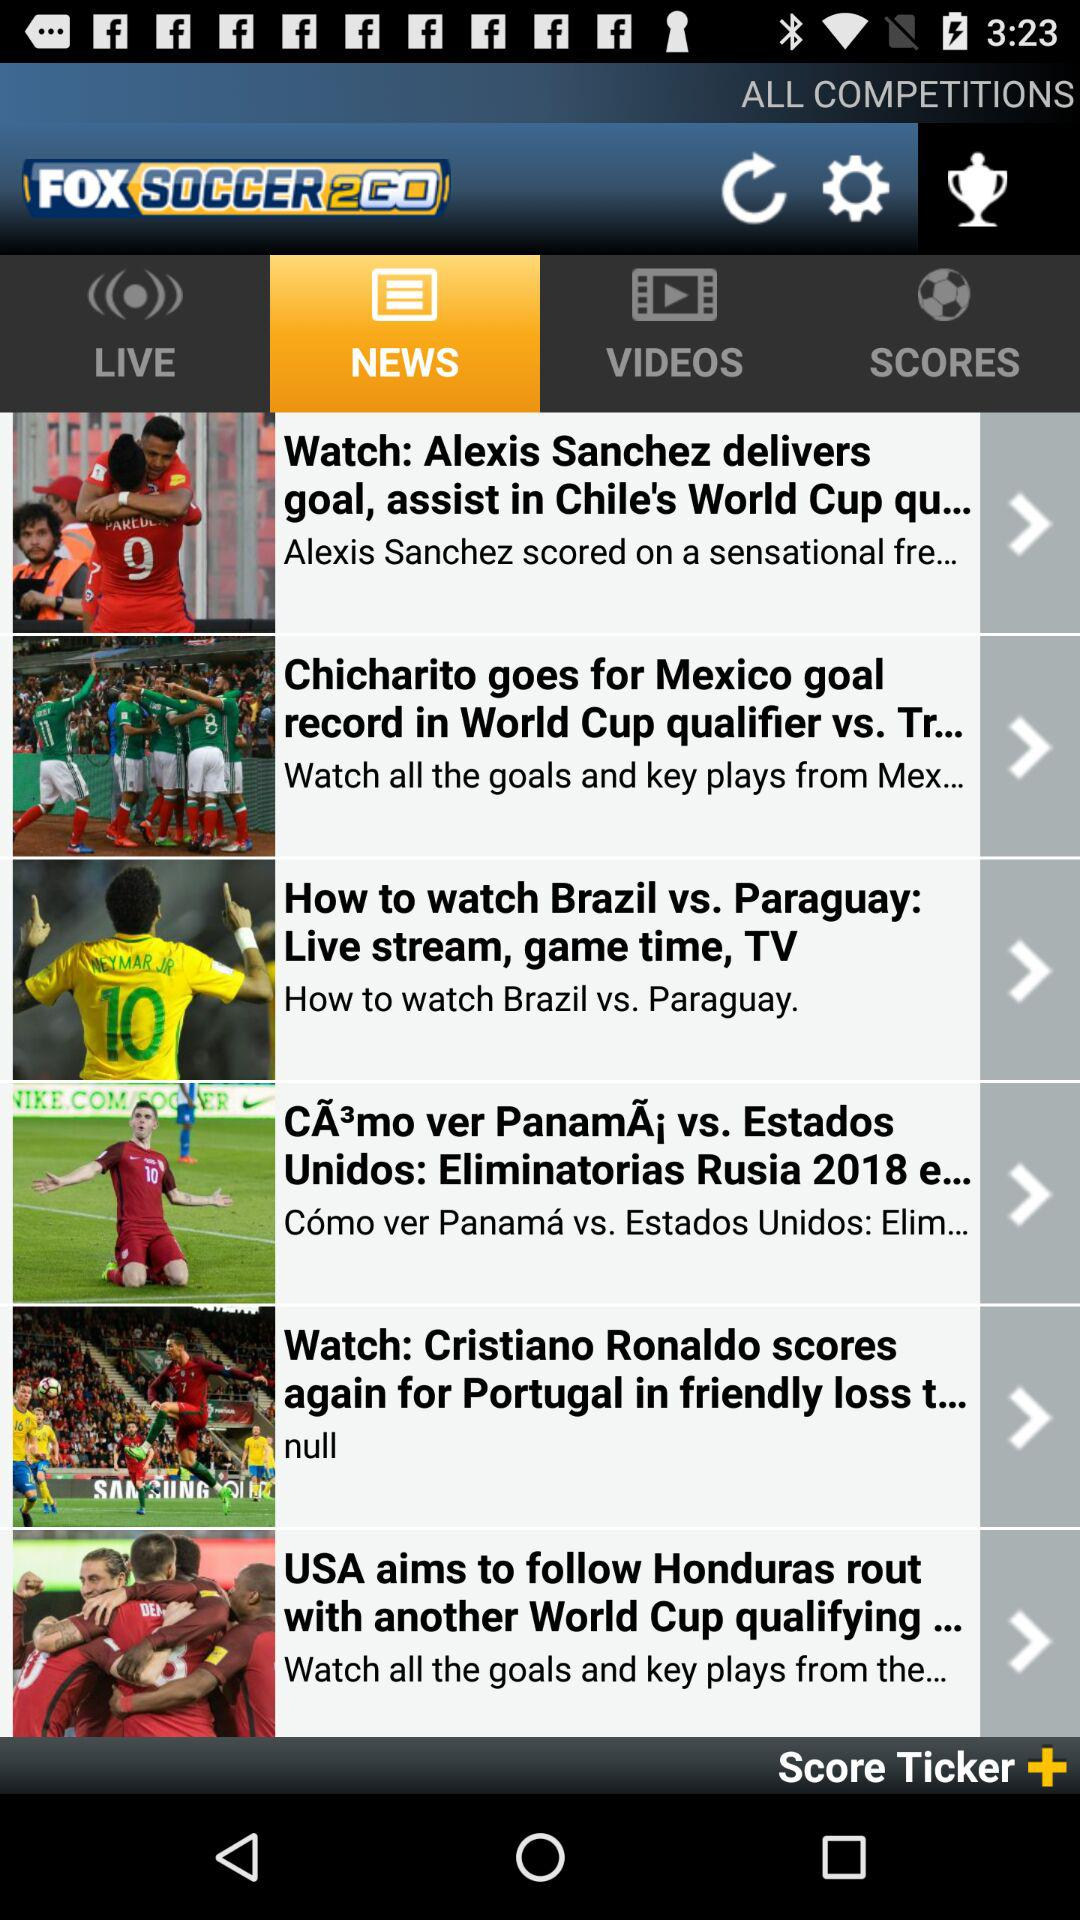Which tab am I using? You are using "NEWS" tab. 